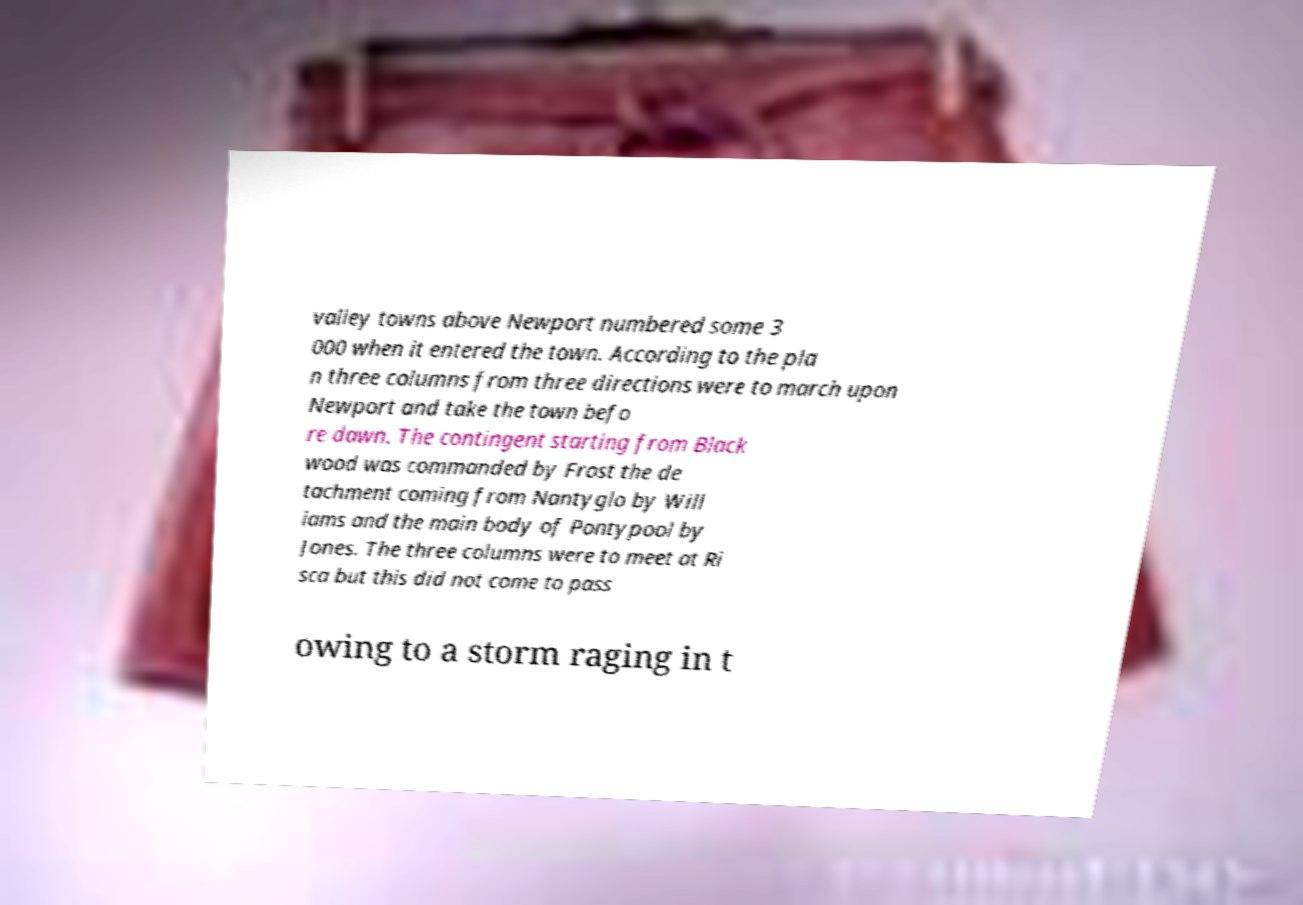Can you accurately transcribe the text from the provided image for me? valley towns above Newport numbered some 3 000 when it entered the town. According to the pla n three columns from three directions were to march upon Newport and take the town befo re dawn. The contingent starting from Black wood was commanded by Frost the de tachment coming from Nantyglo by Will iams and the main body of Pontypool by Jones. The three columns were to meet at Ri sca but this did not come to pass owing to a storm raging in t 